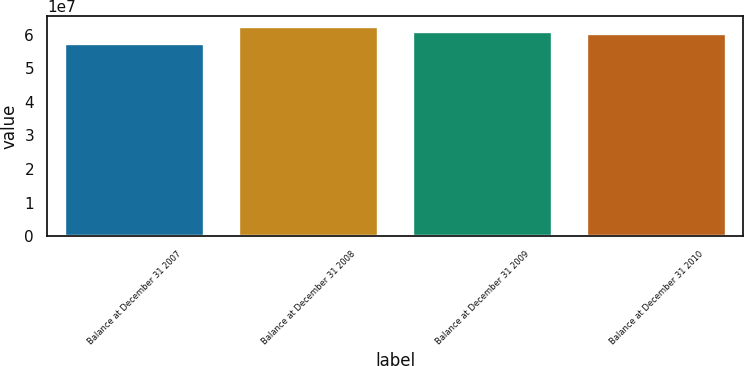Convert chart. <chart><loc_0><loc_0><loc_500><loc_500><bar_chart><fcel>Balance at December 31 2007<fcel>Balance at December 31 2008<fcel>Balance at December 31 2009<fcel>Balance at December 31 2010<nl><fcel>5.72027e+07<fcel>6.23536e+07<fcel>6.07608e+07<fcel>6.02457e+07<nl></chart> 